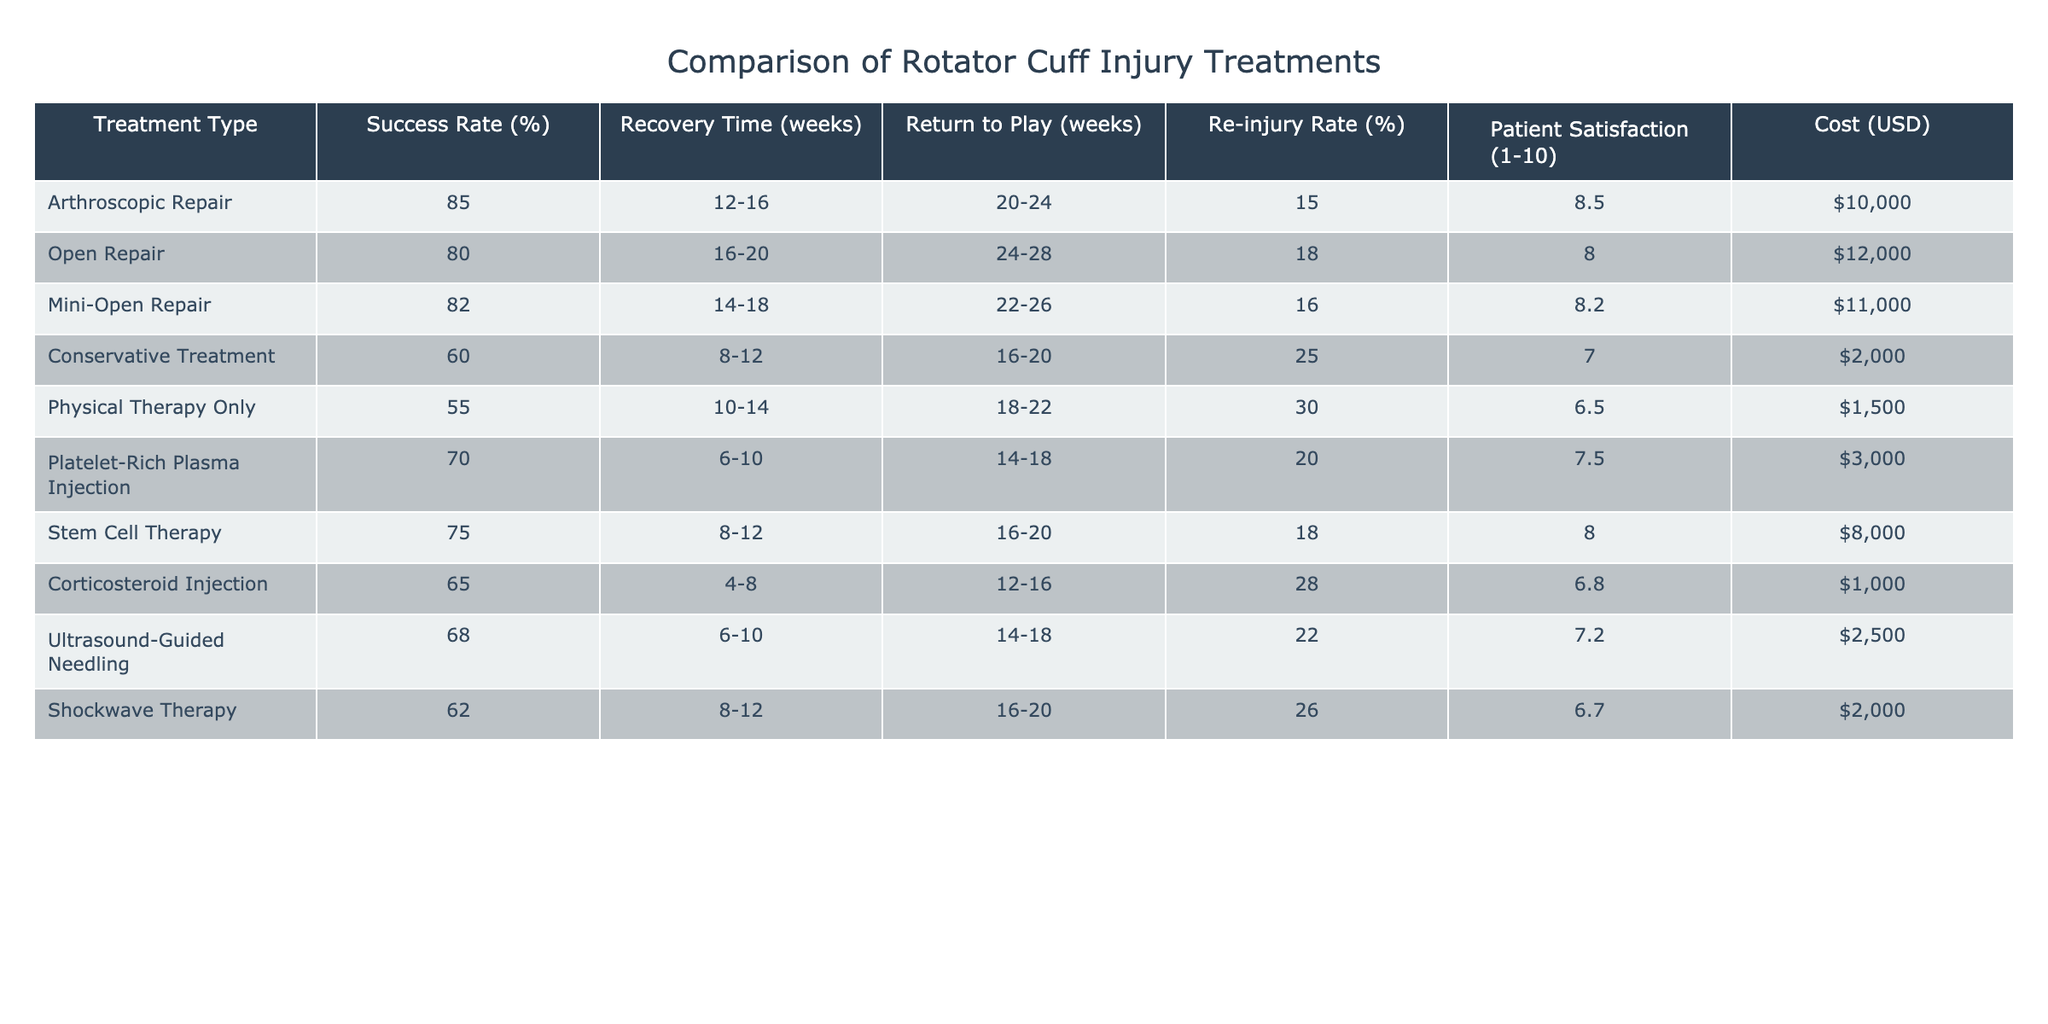What is the success rate of the Arthroscopic Repair treatment? According to the table, the success rate for the Arthroscopic Repair treatment is listed directly under the "Success Rate (%)" column. It shows a value of 85%.
Answer: 85% Which treatment has the highest patient satisfaction score? By looking at the "Patient Satisfaction (1-10)" column, the Arthroscopic Repair has the highest score at 8.5.
Answer: Arthroscopic Repair What is the average recovery time for the non-surgical treatments? The non-surgical treatments are Conservative Treatment, Physical Therapy Only, Platelet-Rich Plasma Injection, Corticosteroid Injection, Ultrasound-Guided Needling, and Shockwave Therapy. Their recovery times are: 8-12, 10-14, 6-10, 4-8, 6-10, and 8-12 weeks respectively. Converting these to weeks gives an average of (10 + 12 + 8 + 6 + 8 + 10)/6 = 54/6 = 9 weeks.
Answer: 9 weeks Is the re-injury rate higher for Open Repair compared to Mini-Open Repair? The re-injury rate for Open Repair is 18%, while for Mini-Open Repair it is 16%. Since 18% is greater than 16%, the statement is true.
Answer: Yes What is the cost difference between the most expensive surgical treatment and the least expensive non-surgical treatment? The most expensive surgical treatment is Open Repair at $12,000, and the least expensive non-surgical treatment is Physical Therapy Only at $1,500. The cost difference is calculated as $12,000 - $1,500 = $10,500.
Answer: $10,500 What percentage of patients are satisfied with Stem Cell Therapy? Looking at the table, the patient satisfaction score for Stem Cell Therapy is listed as 8.0 under the "Patient Satisfaction (1-10)" column.
Answer: 8.0 If a patient chooses Conservative Treatment, what is the duration until they can return to play? According to the table, the return to play duration for Conservative Treatment is listed as 16-20 weeks. This means, on average, they could return to play around 18 weeks.
Answer: 18 weeks Which treatment has the lowest success rate and what is that rate? The treatment with the lowest success rate is Physical Therapy Only, which has a success rate of 55%.
Answer: 55% What re-injury rate corresponds to the second most successful surgical treatment? The second most successful surgical treatment is Mini-Open Repair with a success rate of 82%. Its re-injury rate is listed as 16%.
Answer: 16% 